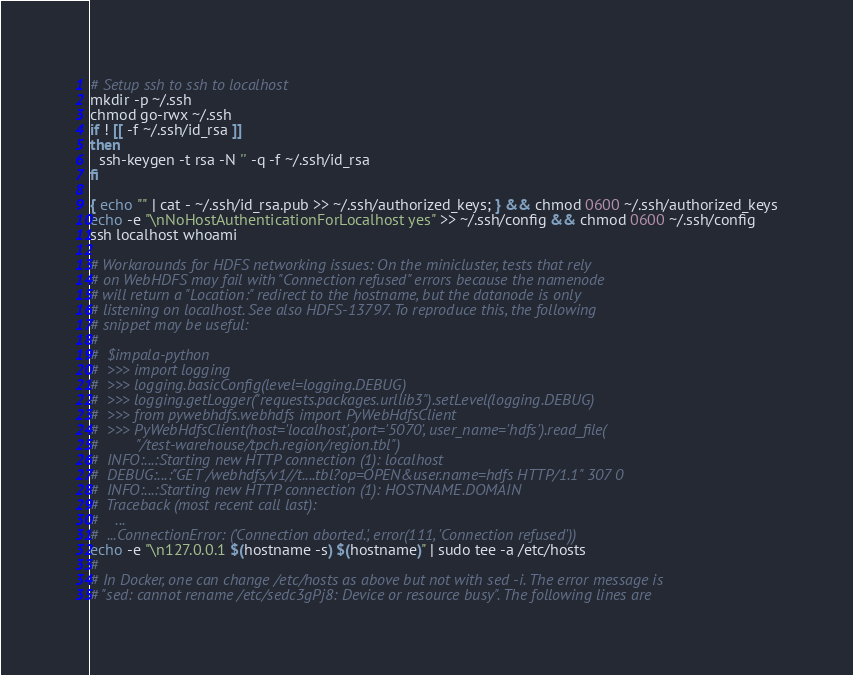Convert code to text. <code><loc_0><loc_0><loc_500><loc_500><_Bash_># Setup ssh to ssh to localhost
mkdir -p ~/.ssh
chmod go-rwx ~/.ssh
if ! [[ -f ~/.ssh/id_rsa ]]
then
  ssh-keygen -t rsa -N '' -q -f ~/.ssh/id_rsa
fi

{ echo "" | cat - ~/.ssh/id_rsa.pub >> ~/.ssh/authorized_keys; } && chmod 0600 ~/.ssh/authorized_keys
echo -e "\nNoHostAuthenticationForLocalhost yes" >> ~/.ssh/config && chmod 0600 ~/.ssh/config
ssh localhost whoami

# Workarounds for HDFS networking issues: On the minicluster, tests that rely
# on WebHDFS may fail with "Connection refused" errors because the namenode
# will return a "Location:" redirect to the hostname, but the datanode is only
# listening on localhost. See also HDFS-13797. To reproduce this, the following
# snippet may be useful:
#
#  $impala-python
#  >>> import logging
#  >>> logging.basicConfig(level=logging.DEBUG)
#  >>> logging.getLogger("requests.packages.urllib3").setLevel(logging.DEBUG)
#  >>> from pywebhdfs.webhdfs import PyWebHdfsClient
#  >>> PyWebHdfsClient(host='localhost',port='5070', user_name='hdfs').read_file(
#         "/test-warehouse/tpch.region/region.tbl")
#  INFO:...:Starting new HTTP connection (1): localhost
#  DEBUG:...:"GET /webhdfs/v1//t....tbl?op=OPEN&user.name=hdfs HTTP/1.1" 307 0
#  INFO:...:Starting new HTTP connection (1): HOSTNAME.DOMAIN
#  Traceback (most recent call last):
#    ...
#  ...ConnectionError: ('Connection aborted.', error(111, 'Connection refused'))
echo -e "\n127.0.0.1 $(hostname -s) $(hostname)" | sudo tee -a /etc/hosts
#
# In Docker, one can change /etc/hosts as above but not with sed -i. The error message is
# "sed: cannot rename /etc/sedc3gPj8: Device or resource busy". The following lines are</code> 